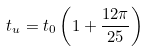Convert formula to latex. <formula><loc_0><loc_0><loc_500><loc_500>t _ { u } = t _ { 0 } \left ( 1 + \frac { 1 2 \pi } { 2 5 } \right )</formula> 